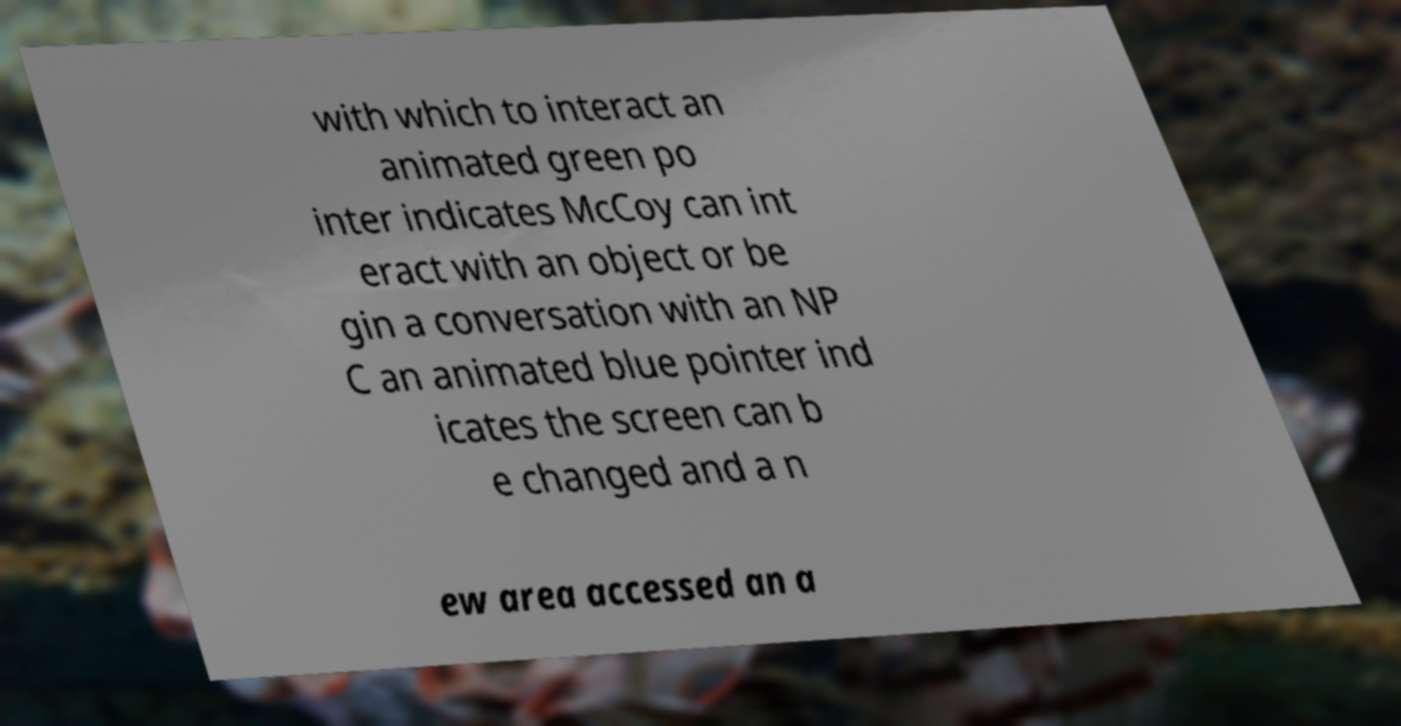Please read and relay the text visible in this image. What does it say? with which to interact an animated green po inter indicates McCoy can int eract with an object or be gin a conversation with an NP C an animated blue pointer ind icates the screen can b e changed and a n ew area accessed an a 